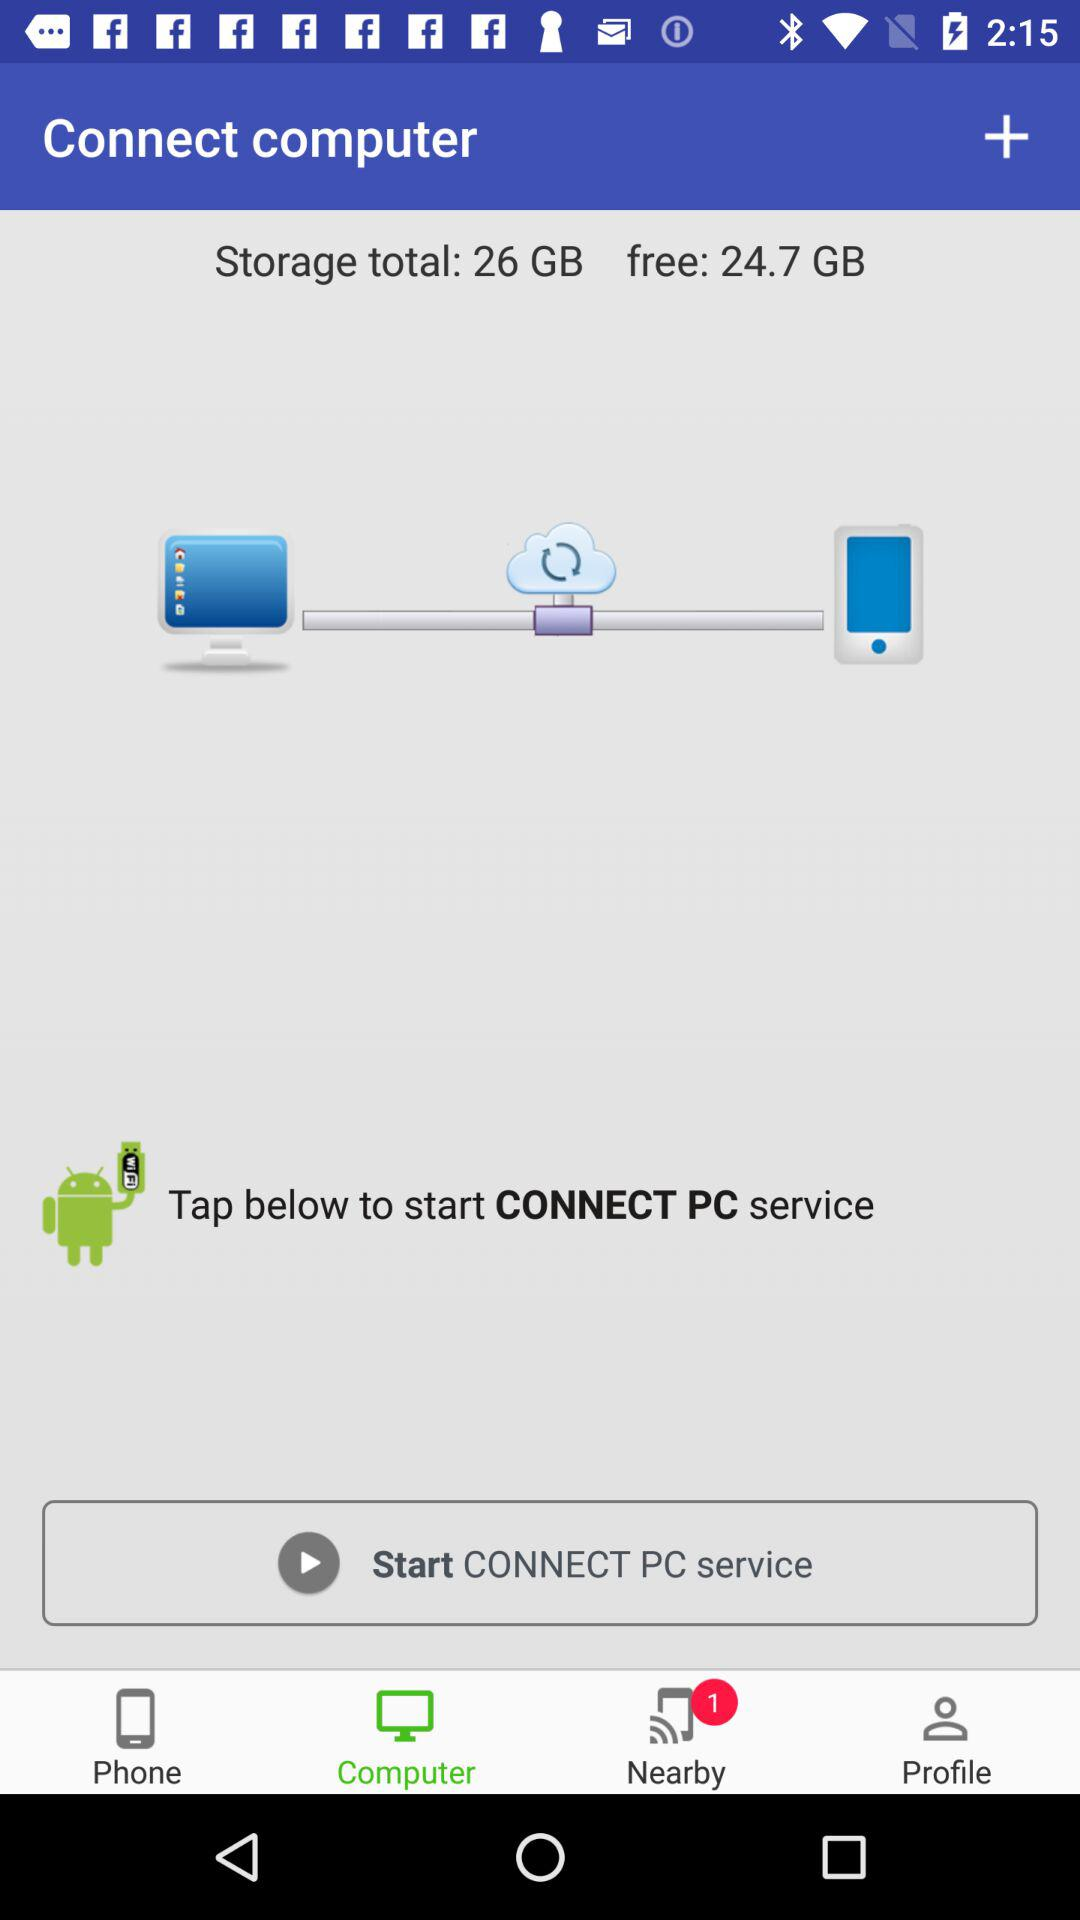What is the total storage of the system? The total storage is 26 GB. 